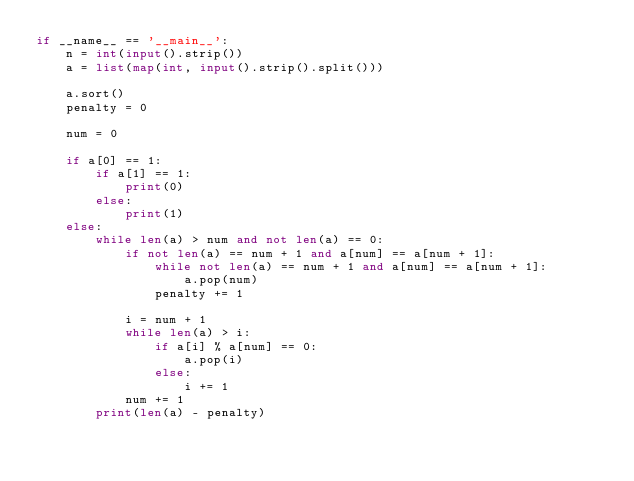<code> <loc_0><loc_0><loc_500><loc_500><_Python_>if __name__ == '__main__':
    n = int(input().strip())
    a = list(map(int, input().strip().split()))

    a.sort()
    penalty = 0

    num = 0

    if a[0] == 1:
        if a[1] == 1:
            print(0)
        else:
            print(1)
    else:
        while len(a) > num and not len(a) == 0:
            if not len(a) == num + 1 and a[num] == a[num + 1]:
                while not len(a) == num + 1 and a[num] == a[num + 1]:
                    a.pop(num)
                penalty += 1

            i = num + 1
            while len(a) > i:
                if a[i] % a[num] == 0:
                    a.pop(i)
                else:
                    i += 1
            num += 1
        print(len(a) - penalty)
</code> 